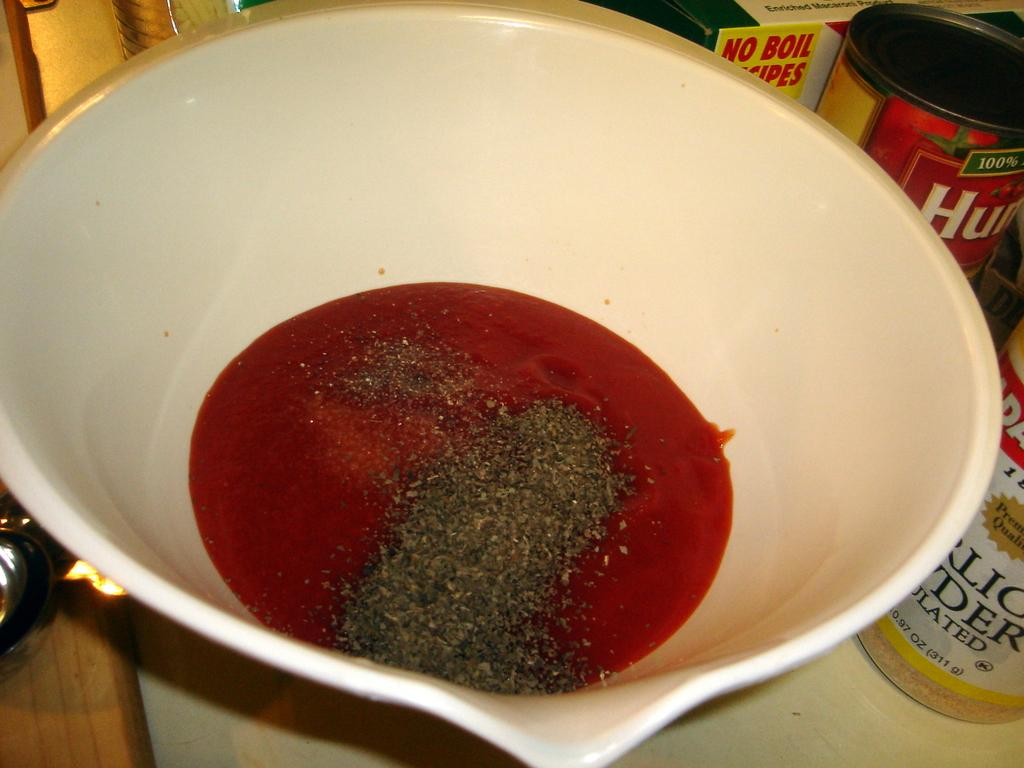What is in the bowl that is visible in the image? The bowl contains liquid and powder in the image. What else can be seen on the platform in the image? There are bottles and a box on the platform in the image. What type of rake is being used to sort the bottles on the platform? There is no rake present in the image, and the bottles are not being sorted. 